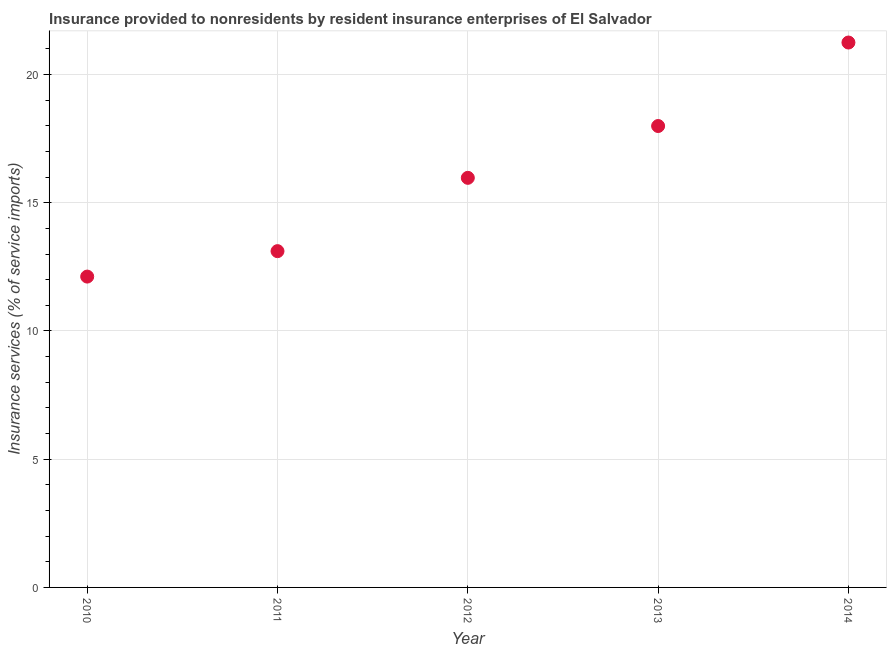What is the insurance and financial services in 2011?
Offer a terse response. 13.11. Across all years, what is the maximum insurance and financial services?
Your answer should be compact. 21.25. Across all years, what is the minimum insurance and financial services?
Offer a terse response. 12.12. In which year was the insurance and financial services maximum?
Offer a very short reply. 2014. What is the sum of the insurance and financial services?
Give a very brief answer. 80.45. What is the difference between the insurance and financial services in 2010 and 2011?
Keep it short and to the point. -0.99. What is the average insurance and financial services per year?
Provide a short and direct response. 16.09. What is the median insurance and financial services?
Your answer should be very brief. 15.97. In how many years, is the insurance and financial services greater than 16 %?
Keep it short and to the point. 2. What is the ratio of the insurance and financial services in 2010 to that in 2013?
Your answer should be compact. 0.67. What is the difference between the highest and the second highest insurance and financial services?
Provide a short and direct response. 3.26. What is the difference between the highest and the lowest insurance and financial services?
Give a very brief answer. 9.13. Are the values on the major ticks of Y-axis written in scientific E-notation?
Offer a very short reply. No. Does the graph contain grids?
Keep it short and to the point. Yes. What is the title of the graph?
Provide a succinct answer. Insurance provided to nonresidents by resident insurance enterprises of El Salvador. What is the label or title of the X-axis?
Your response must be concise. Year. What is the label or title of the Y-axis?
Your answer should be compact. Insurance services (% of service imports). What is the Insurance services (% of service imports) in 2010?
Provide a short and direct response. 12.12. What is the Insurance services (% of service imports) in 2011?
Your answer should be very brief. 13.11. What is the Insurance services (% of service imports) in 2012?
Your answer should be very brief. 15.97. What is the Insurance services (% of service imports) in 2013?
Your response must be concise. 17.99. What is the Insurance services (% of service imports) in 2014?
Offer a terse response. 21.25. What is the difference between the Insurance services (% of service imports) in 2010 and 2011?
Keep it short and to the point. -0.99. What is the difference between the Insurance services (% of service imports) in 2010 and 2012?
Provide a succinct answer. -3.85. What is the difference between the Insurance services (% of service imports) in 2010 and 2013?
Provide a succinct answer. -5.87. What is the difference between the Insurance services (% of service imports) in 2010 and 2014?
Make the answer very short. -9.13. What is the difference between the Insurance services (% of service imports) in 2011 and 2012?
Provide a short and direct response. -2.86. What is the difference between the Insurance services (% of service imports) in 2011 and 2013?
Offer a terse response. -4.88. What is the difference between the Insurance services (% of service imports) in 2011 and 2014?
Give a very brief answer. -8.14. What is the difference between the Insurance services (% of service imports) in 2012 and 2013?
Provide a succinct answer. -2.02. What is the difference between the Insurance services (% of service imports) in 2012 and 2014?
Ensure brevity in your answer.  -5.28. What is the difference between the Insurance services (% of service imports) in 2013 and 2014?
Ensure brevity in your answer.  -3.26. What is the ratio of the Insurance services (% of service imports) in 2010 to that in 2011?
Provide a succinct answer. 0.92. What is the ratio of the Insurance services (% of service imports) in 2010 to that in 2012?
Offer a very short reply. 0.76. What is the ratio of the Insurance services (% of service imports) in 2010 to that in 2013?
Offer a very short reply. 0.67. What is the ratio of the Insurance services (% of service imports) in 2010 to that in 2014?
Keep it short and to the point. 0.57. What is the ratio of the Insurance services (% of service imports) in 2011 to that in 2012?
Make the answer very short. 0.82. What is the ratio of the Insurance services (% of service imports) in 2011 to that in 2013?
Your response must be concise. 0.73. What is the ratio of the Insurance services (% of service imports) in 2011 to that in 2014?
Keep it short and to the point. 0.62. What is the ratio of the Insurance services (% of service imports) in 2012 to that in 2013?
Offer a very short reply. 0.89. What is the ratio of the Insurance services (% of service imports) in 2012 to that in 2014?
Provide a short and direct response. 0.75. What is the ratio of the Insurance services (% of service imports) in 2013 to that in 2014?
Your answer should be compact. 0.85. 